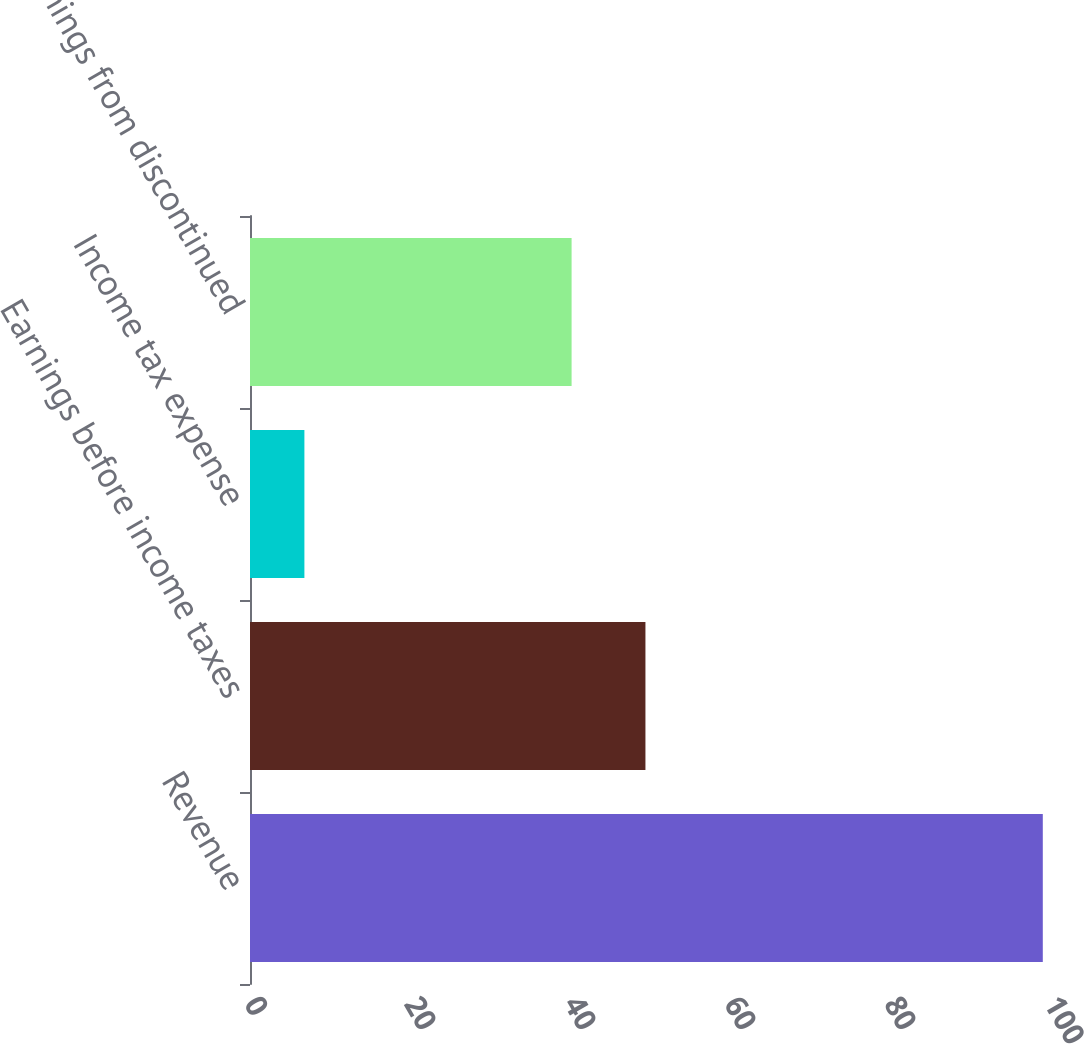Convert chart to OTSL. <chart><loc_0><loc_0><loc_500><loc_500><bar_chart><fcel>Revenue<fcel>Earnings before income taxes<fcel>Income tax expense<fcel>Earnings from discontinued<nl><fcel>99.1<fcel>49.43<fcel>6.8<fcel>40.2<nl></chart> 